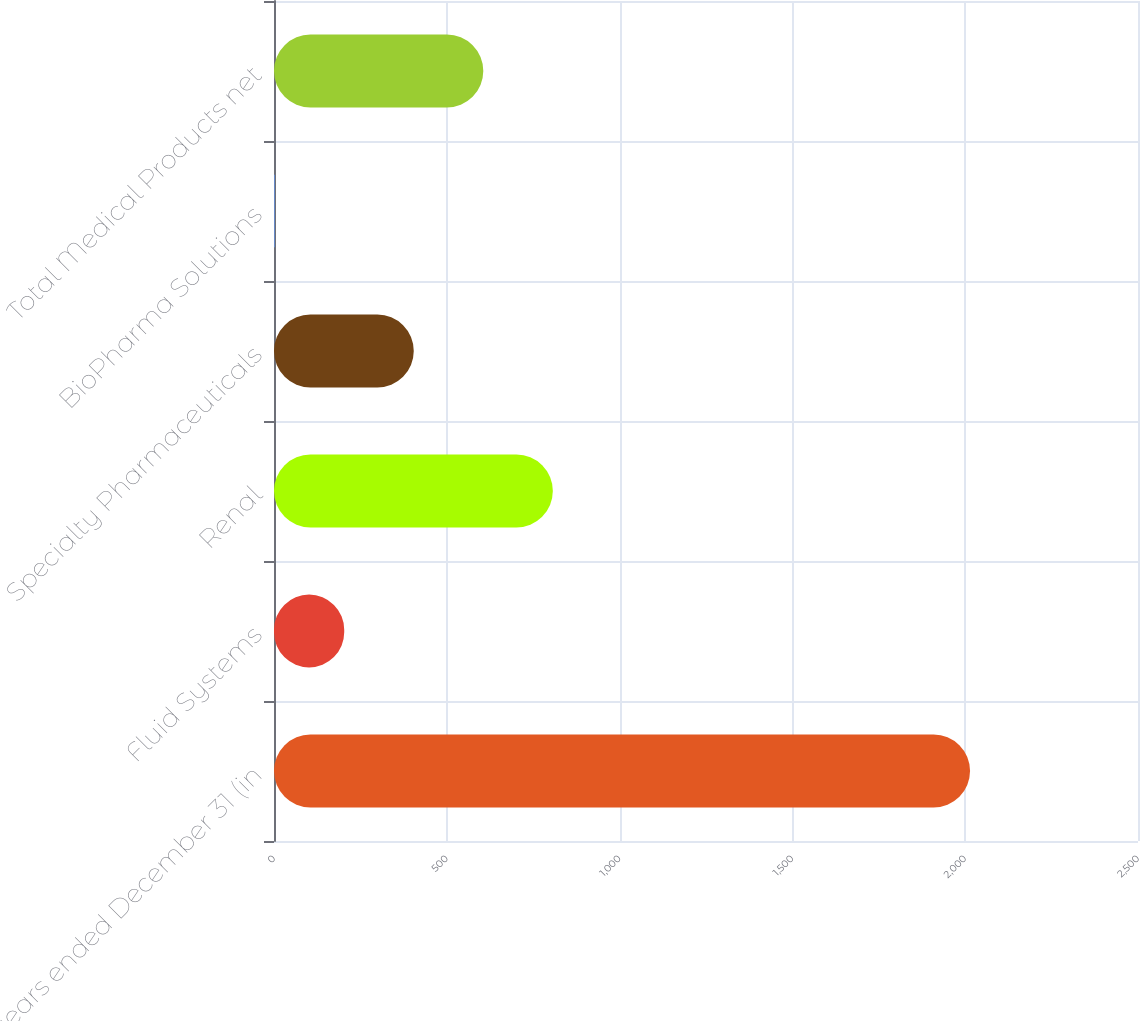Convert chart to OTSL. <chart><loc_0><loc_0><loc_500><loc_500><bar_chart><fcel>years ended December 31 (in<fcel>Fluid Systems<fcel>Renal<fcel>Specialty Pharmaceuticals<fcel>BioPharma Solutions<fcel>Total Medical Products net<nl><fcel>2014<fcel>203.2<fcel>806.8<fcel>404.4<fcel>2<fcel>605.6<nl></chart> 